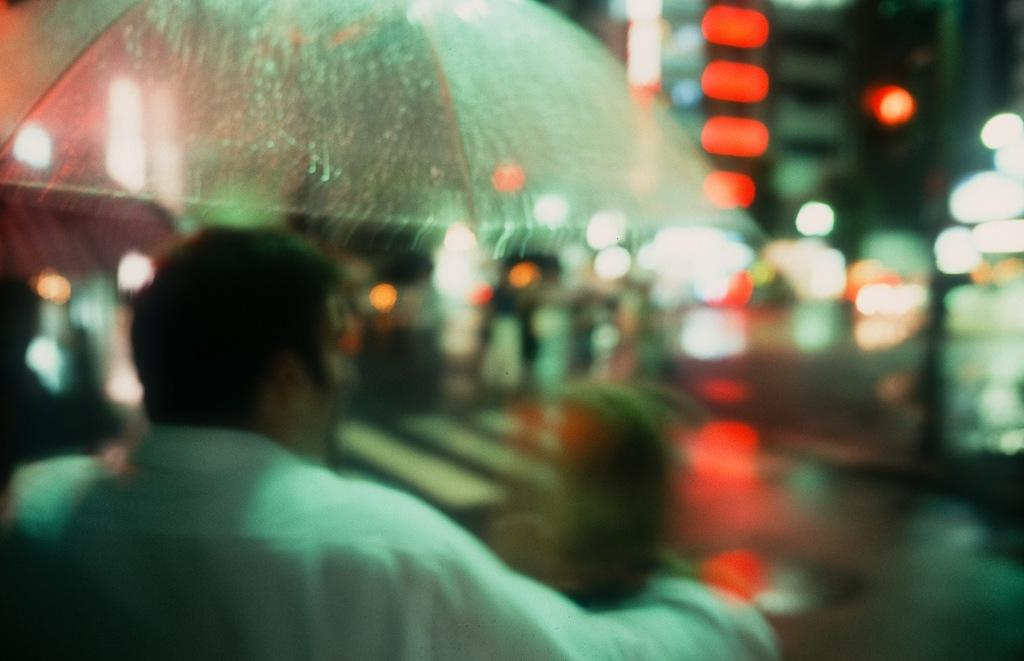What is the weather like in the image? It is raining. How many dogs are playing in the middle of the image? There are no dogs present in the image, as it only mentions that it is raining. 